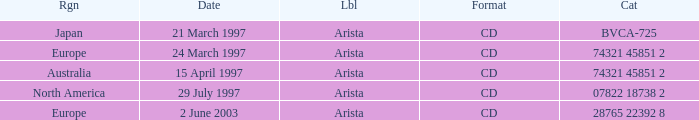What Label has the Region of Australia? Arista. 